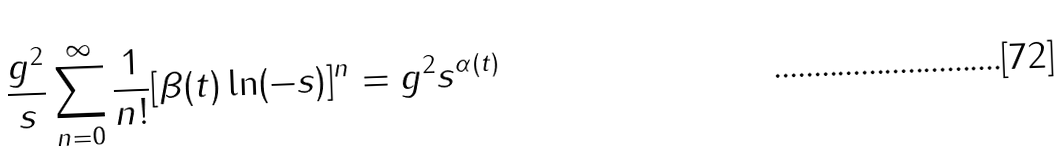<formula> <loc_0><loc_0><loc_500><loc_500>\frac { g ^ { 2 } } { s } \sum _ { n = 0 } ^ { \infty } \frac { 1 } { n ! } [ \beta ( t ) \ln ( - s ) ] ^ { n } = g ^ { 2 } s ^ { \alpha ( t ) }</formula> 